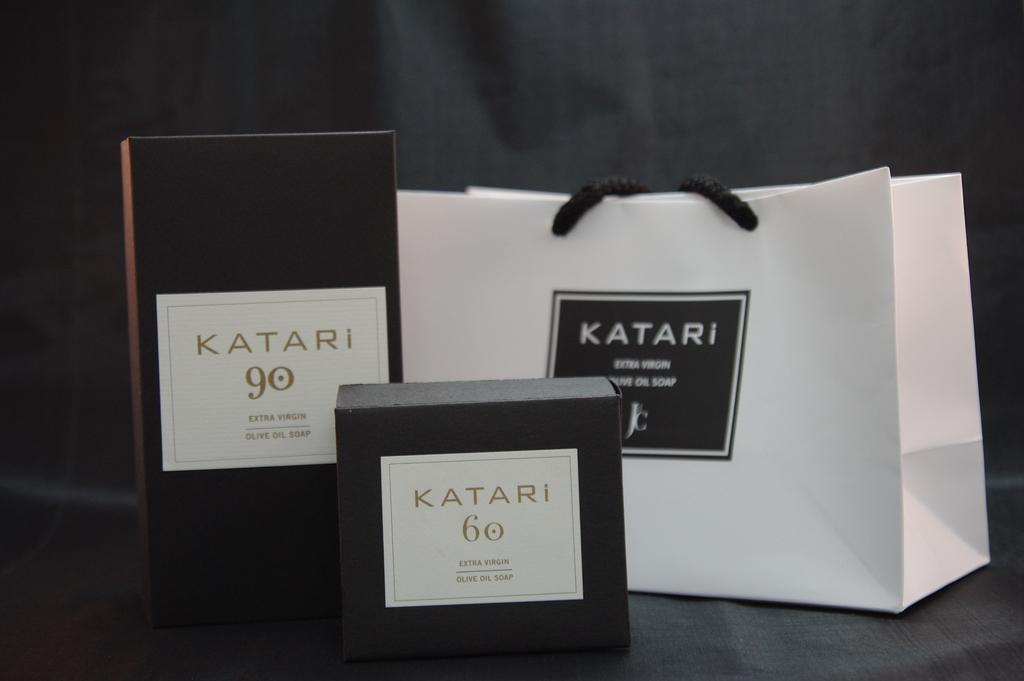<image>
Relay a brief, clear account of the picture shown. Katari bag that is black and white along with katari boxes 